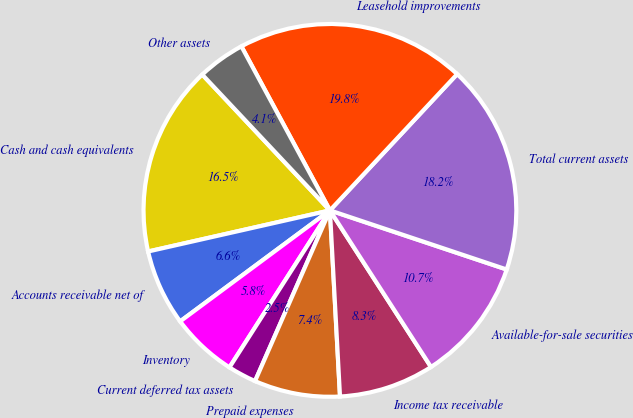Convert chart to OTSL. <chart><loc_0><loc_0><loc_500><loc_500><pie_chart><fcel>Cash and cash equivalents<fcel>Accounts receivable net of<fcel>Inventory<fcel>Current deferred tax assets<fcel>Prepaid expenses<fcel>Income tax receivable<fcel>Available-for-sale securities<fcel>Total current assets<fcel>Leasehold improvements<fcel>Other assets<nl><fcel>16.53%<fcel>6.61%<fcel>5.79%<fcel>2.48%<fcel>7.44%<fcel>8.26%<fcel>10.74%<fcel>18.18%<fcel>19.83%<fcel>4.13%<nl></chart> 